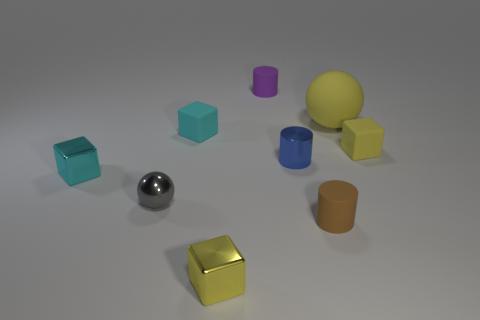Subtract 2 cubes. How many cubes are left? 2 Add 1 big cyan matte objects. How many objects exist? 10 Subtract all cylinders. How many objects are left? 6 Subtract 0 cyan cylinders. How many objects are left? 9 Subtract all green matte blocks. Subtract all tiny yellow matte things. How many objects are left? 8 Add 4 yellow things. How many yellow things are left? 7 Add 5 big green spheres. How many big green spheres exist? 5 